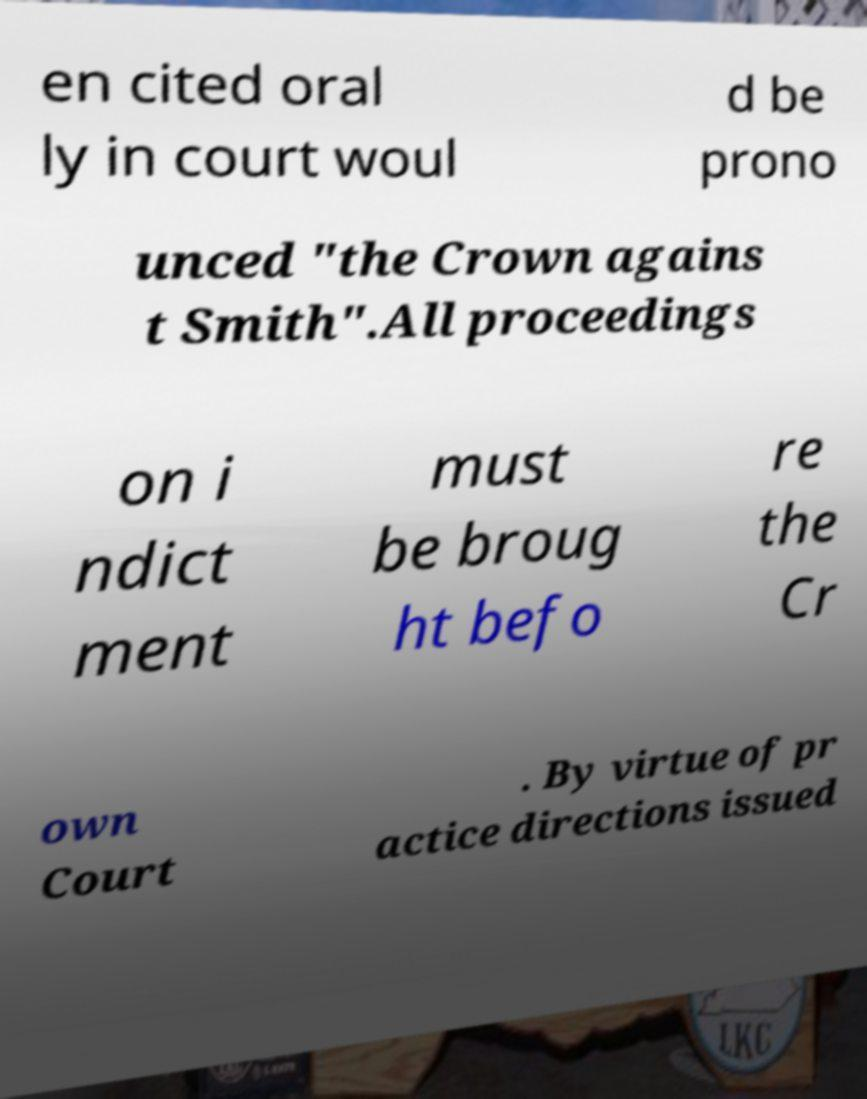There's text embedded in this image that I need extracted. Can you transcribe it verbatim? en cited oral ly in court woul d be prono unced "the Crown agains t Smith".All proceedings on i ndict ment must be broug ht befo re the Cr own Court . By virtue of pr actice directions issued 